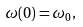<formula> <loc_0><loc_0><loc_500><loc_500>\omega ( 0 ) = \omega _ { 0 } ,</formula> 